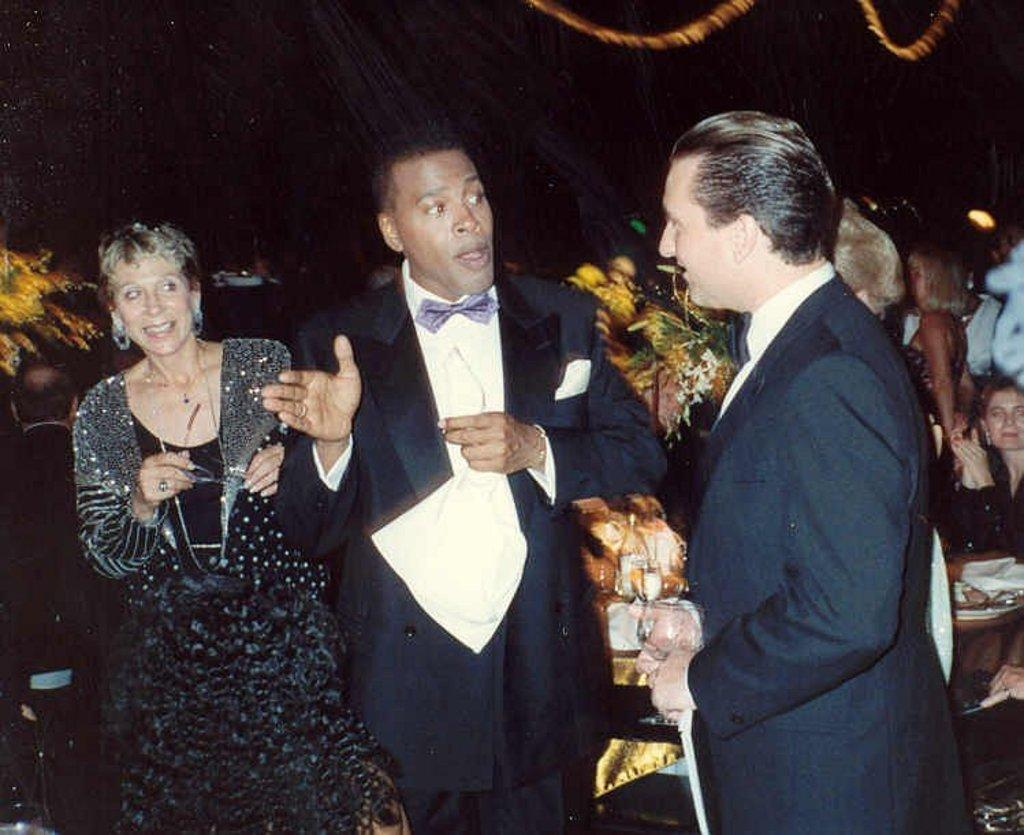What are the people in the image doing? The people in the image are standing and sitting. What are the men wearing in the image? The men are wearing suits in the image. Can you describe the seating arrangement in the image? There are people sitting on chairs in the image. What type of hand can be seen holding a cannon in the image? There is no hand or cannon present in the image. 